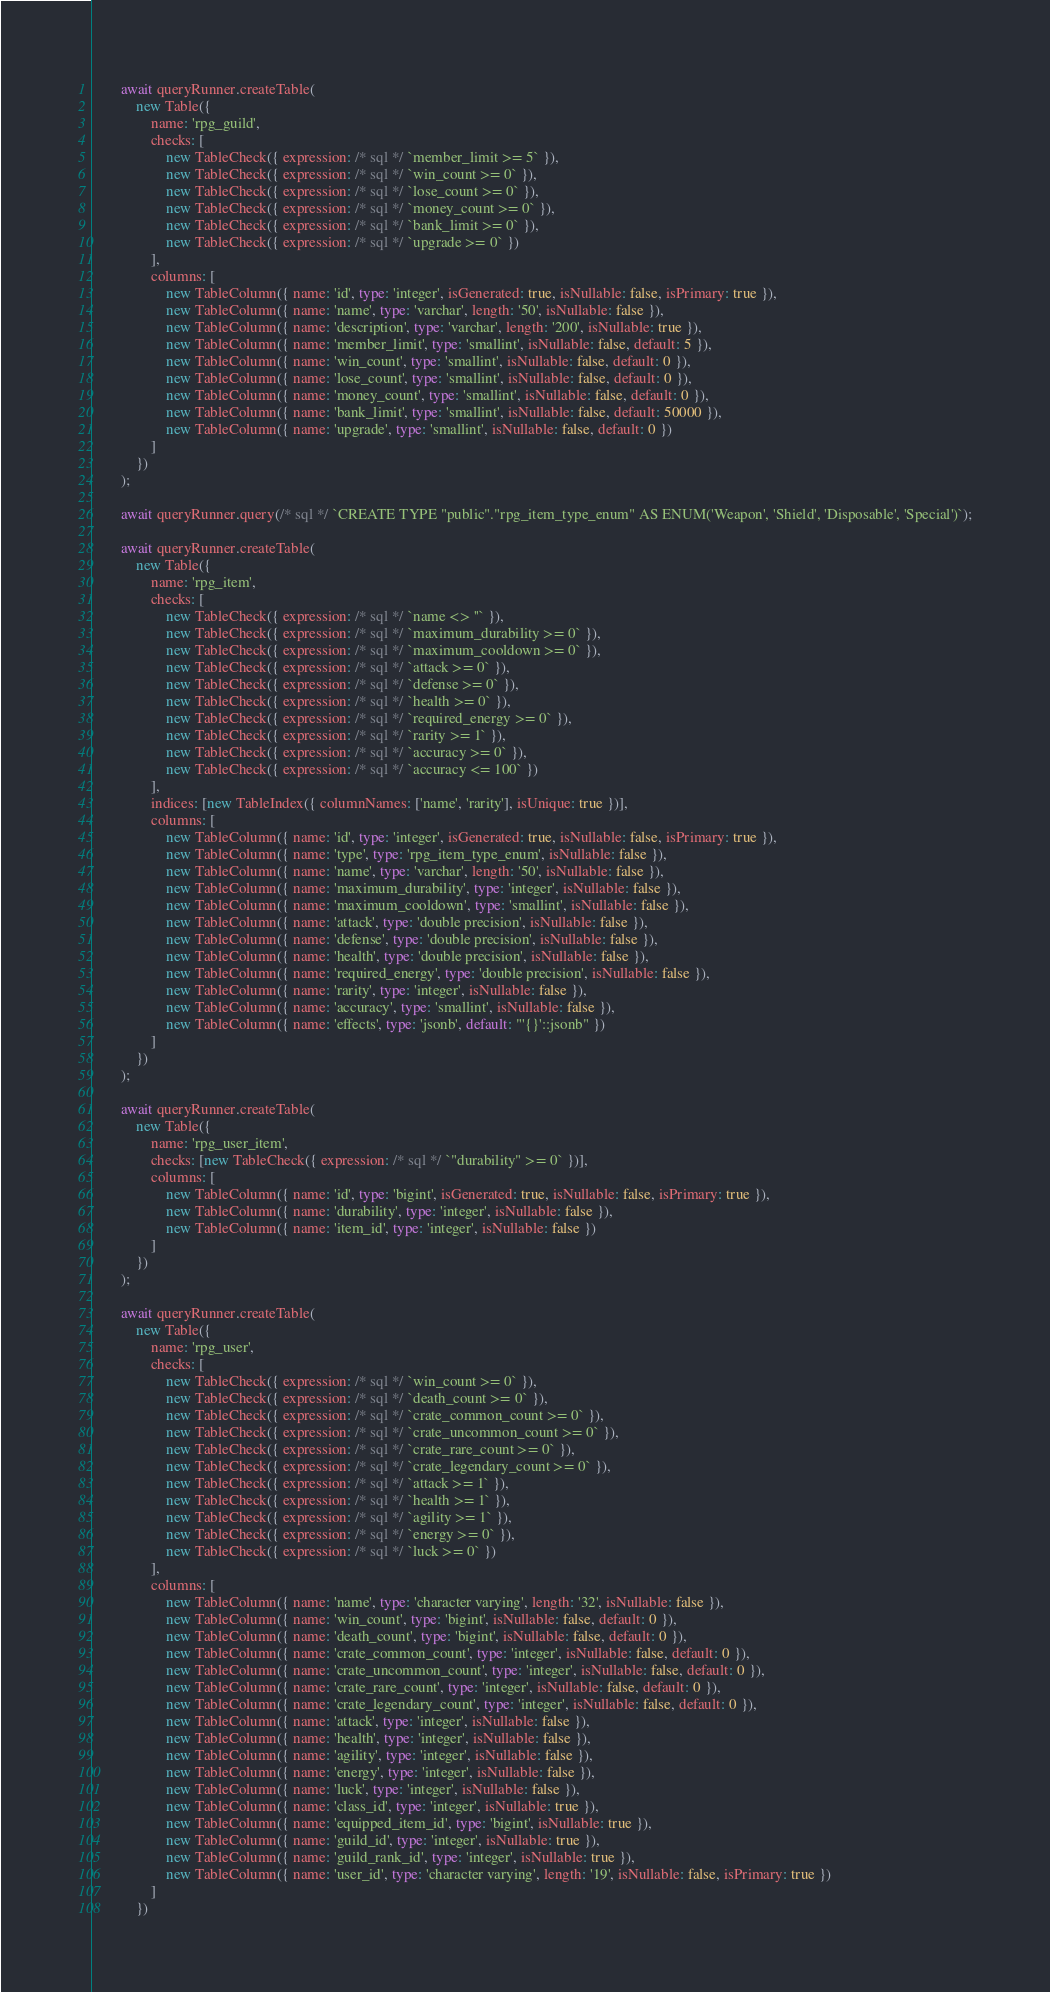Convert code to text. <code><loc_0><loc_0><loc_500><loc_500><_TypeScript_>		await queryRunner.createTable(
			new Table({
				name: 'rpg_guild',
				checks: [
					new TableCheck({ expression: /* sql */ `member_limit >= 5` }),
					new TableCheck({ expression: /* sql */ `win_count >= 0` }),
					new TableCheck({ expression: /* sql */ `lose_count >= 0` }),
					new TableCheck({ expression: /* sql */ `money_count >= 0` }),
					new TableCheck({ expression: /* sql */ `bank_limit >= 0` }),
					new TableCheck({ expression: /* sql */ `upgrade >= 0` })
				],
				columns: [
					new TableColumn({ name: 'id', type: 'integer', isGenerated: true, isNullable: false, isPrimary: true }),
					new TableColumn({ name: 'name', type: 'varchar', length: '50', isNullable: false }),
					new TableColumn({ name: 'description', type: 'varchar', length: '200', isNullable: true }),
					new TableColumn({ name: 'member_limit', type: 'smallint', isNullable: false, default: 5 }),
					new TableColumn({ name: 'win_count', type: 'smallint', isNullable: false, default: 0 }),
					new TableColumn({ name: 'lose_count', type: 'smallint', isNullable: false, default: 0 }),
					new TableColumn({ name: 'money_count', type: 'smallint', isNullable: false, default: 0 }),
					new TableColumn({ name: 'bank_limit', type: 'smallint', isNullable: false, default: 50000 }),
					new TableColumn({ name: 'upgrade', type: 'smallint', isNullable: false, default: 0 })
				]
			})
		);

		await queryRunner.query(/* sql */ `CREATE TYPE "public"."rpg_item_type_enum" AS ENUM('Weapon', 'Shield', 'Disposable', 'Special')`);

		await queryRunner.createTable(
			new Table({
				name: 'rpg_item',
				checks: [
					new TableCheck({ expression: /* sql */ `name <> ''` }),
					new TableCheck({ expression: /* sql */ `maximum_durability >= 0` }),
					new TableCheck({ expression: /* sql */ `maximum_cooldown >= 0` }),
					new TableCheck({ expression: /* sql */ `attack >= 0` }),
					new TableCheck({ expression: /* sql */ `defense >= 0` }),
					new TableCheck({ expression: /* sql */ `health >= 0` }),
					new TableCheck({ expression: /* sql */ `required_energy >= 0` }),
					new TableCheck({ expression: /* sql */ `rarity >= 1` }),
					new TableCheck({ expression: /* sql */ `accuracy >= 0` }),
					new TableCheck({ expression: /* sql */ `accuracy <= 100` })
				],
				indices: [new TableIndex({ columnNames: ['name', 'rarity'], isUnique: true })],
				columns: [
					new TableColumn({ name: 'id', type: 'integer', isGenerated: true, isNullable: false, isPrimary: true }),
					new TableColumn({ name: 'type', type: 'rpg_item_type_enum', isNullable: false }),
					new TableColumn({ name: 'name', type: 'varchar', length: '50', isNullable: false }),
					new TableColumn({ name: 'maximum_durability', type: 'integer', isNullable: false }),
					new TableColumn({ name: 'maximum_cooldown', type: 'smallint', isNullable: false }),
					new TableColumn({ name: 'attack', type: 'double precision', isNullable: false }),
					new TableColumn({ name: 'defense', type: 'double precision', isNullable: false }),
					new TableColumn({ name: 'health', type: 'double precision', isNullable: false }),
					new TableColumn({ name: 'required_energy', type: 'double precision', isNullable: false }),
					new TableColumn({ name: 'rarity', type: 'integer', isNullable: false }),
					new TableColumn({ name: 'accuracy', type: 'smallint', isNullable: false }),
					new TableColumn({ name: 'effects', type: 'jsonb', default: "'{}'::jsonb" })
				]
			})
		);

		await queryRunner.createTable(
			new Table({
				name: 'rpg_user_item',
				checks: [new TableCheck({ expression: /* sql */ `"durability" >= 0` })],
				columns: [
					new TableColumn({ name: 'id', type: 'bigint', isGenerated: true, isNullable: false, isPrimary: true }),
					new TableColumn({ name: 'durability', type: 'integer', isNullable: false }),
					new TableColumn({ name: 'item_id', type: 'integer', isNullable: false })
				]
			})
		);

		await queryRunner.createTable(
			new Table({
				name: 'rpg_user',
				checks: [
					new TableCheck({ expression: /* sql */ `win_count >= 0` }),
					new TableCheck({ expression: /* sql */ `death_count >= 0` }),
					new TableCheck({ expression: /* sql */ `crate_common_count >= 0` }),
					new TableCheck({ expression: /* sql */ `crate_uncommon_count >= 0` }),
					new TableCheck({ expression: /* sql */ `crate_rare_count >= 0` }),
					new TableCheck({ expression: /* sql */ `crate_legendary_count >= 0` }),
					new TableCheck({ expression: /* sql */ `attack >= 1` }),
					new TableCheck({ expression: /* sql */ `health >= 1` }),
					new TableCheck({ expression: /* sql */ `agility >= 1` }),
					new TableCheck({ expression: /* sql */ `energy >= 0` }),
					new TableCheck({ expression: /* sql */ `luck >= 0` })
				],
				columns: [
					new TableColumn({ name: 'name', type: 'character varying', length: '32', isNullable: false }),
					new TableColumn({ name: 'win_count', type: 'bigint', isNullable: false, default: 0 }),
					new TableColumn({ name: 'death_count', type: 'bigint', isNullable: false, default: 0 }),
					new TableColumn({ name: 'crate_common_count', type: 'integer', isNullable: false, default: 0 }),
					new TableColumn({ name: 'crate_uncommon_count', type: 'integer', isNullable: false, default: 0 }),
					new TableColumn({ name: 'crate_rare_count', type: 'integer', isNullable: false, default: 0 }),
					new TableColumn({ name: 'crate_legendary_count', type: 'integer', isNullable: false, default: 0 }),
					new TableColumn({ name: 'attack', type: 'integer', isNullable: false }),
					new TableColumn({ name: 'health', type: 'integer', isNullable: false }),
					new TableColumn({ name: 'agility', type: 'integer', isNullable: false }),
					new TableColumn({ name: 'energy', type: 'integer', isNullable: false }),
					new TableColumn({ name: 'luck', type: 'integer', isNullable: false }),
					new TableColumn({ name: 'class_id', type: 'integer', isNullable: true }),
					new TableColumn({ name: 'equipped_item_id', type: 'bigint', isNullable: true }),
					new TableColumn({ name: 'guild_id', type: 'integer', isNullable: true }),
					new TableColumn({ name: 'guild_rank_id', type: 'integer', isNullable: true }),
					new TableColumn({ name: 'user_id', type: 'character varying', length: '19', isNullable: false, isPrimary: true })
				]
			})</code> 